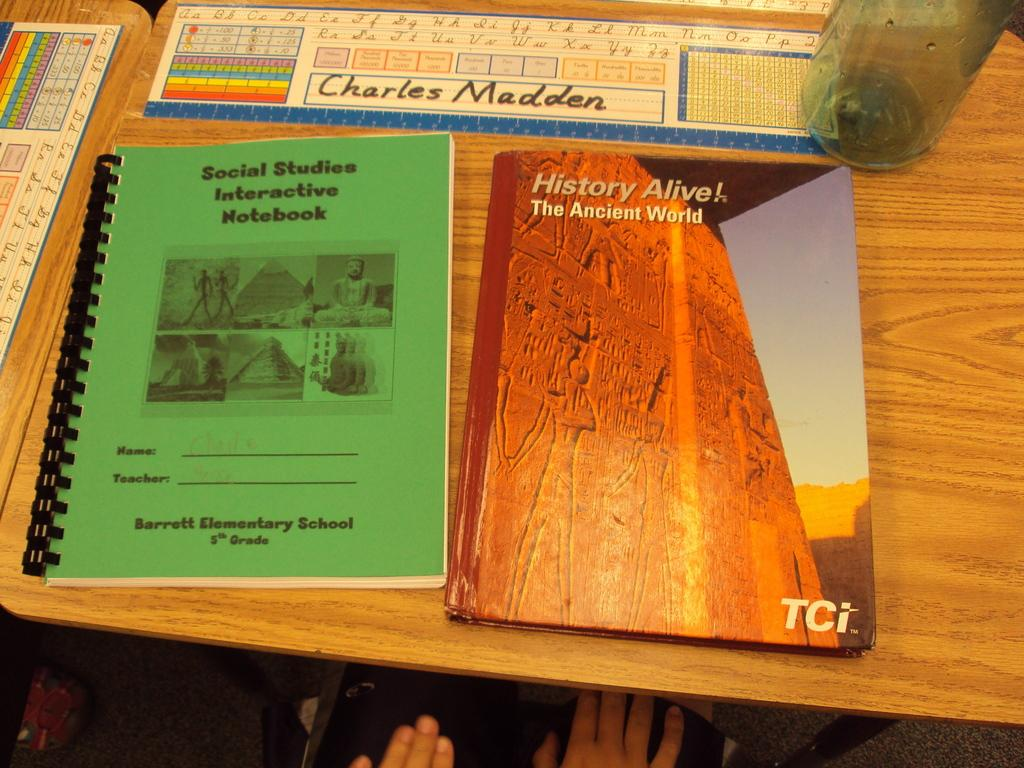Provide a one-sentence caption for the provided image. A green workbook, and a text book titled History Alive next to each other on a desk. 